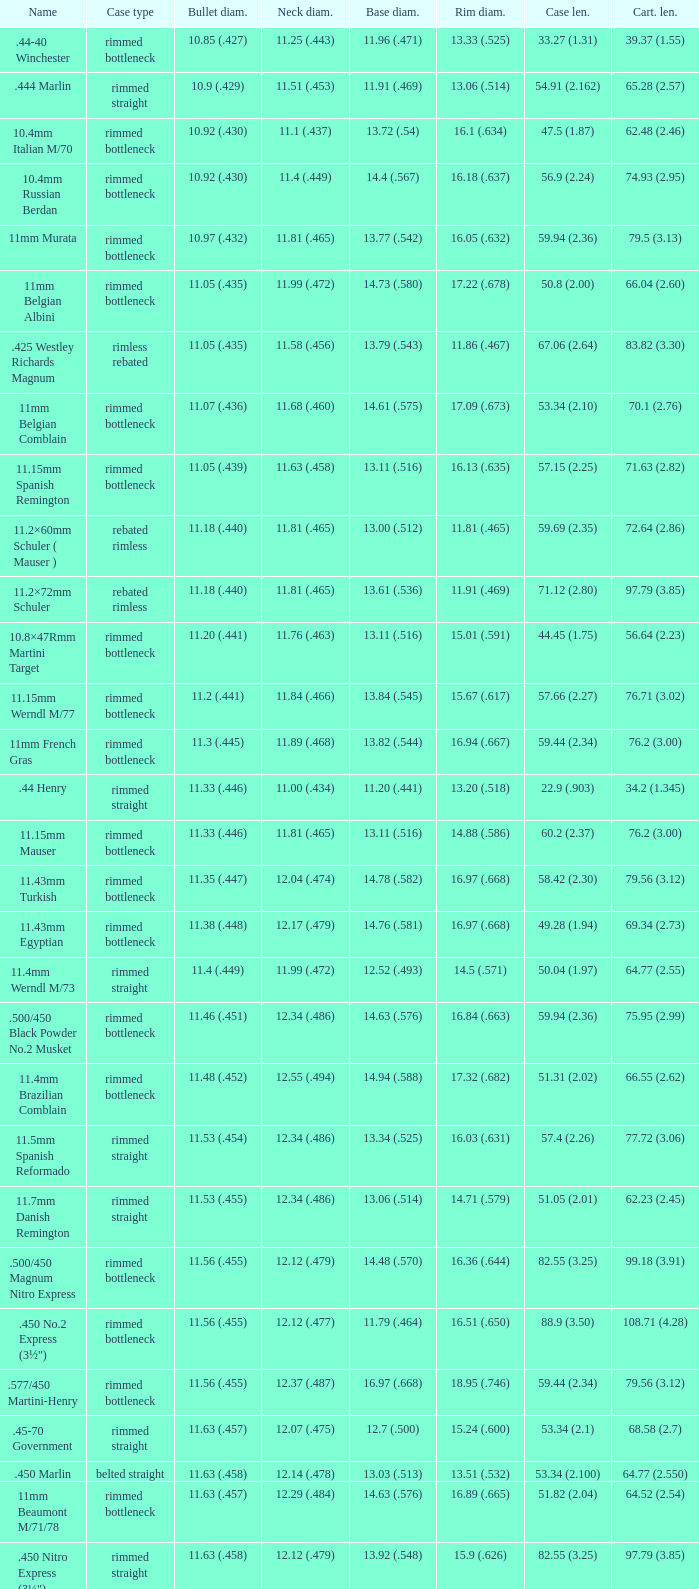Which Case type has a Base diameter of 13.03 (.513), and a Case length of 63.5 (2.5)? Belted straight. 